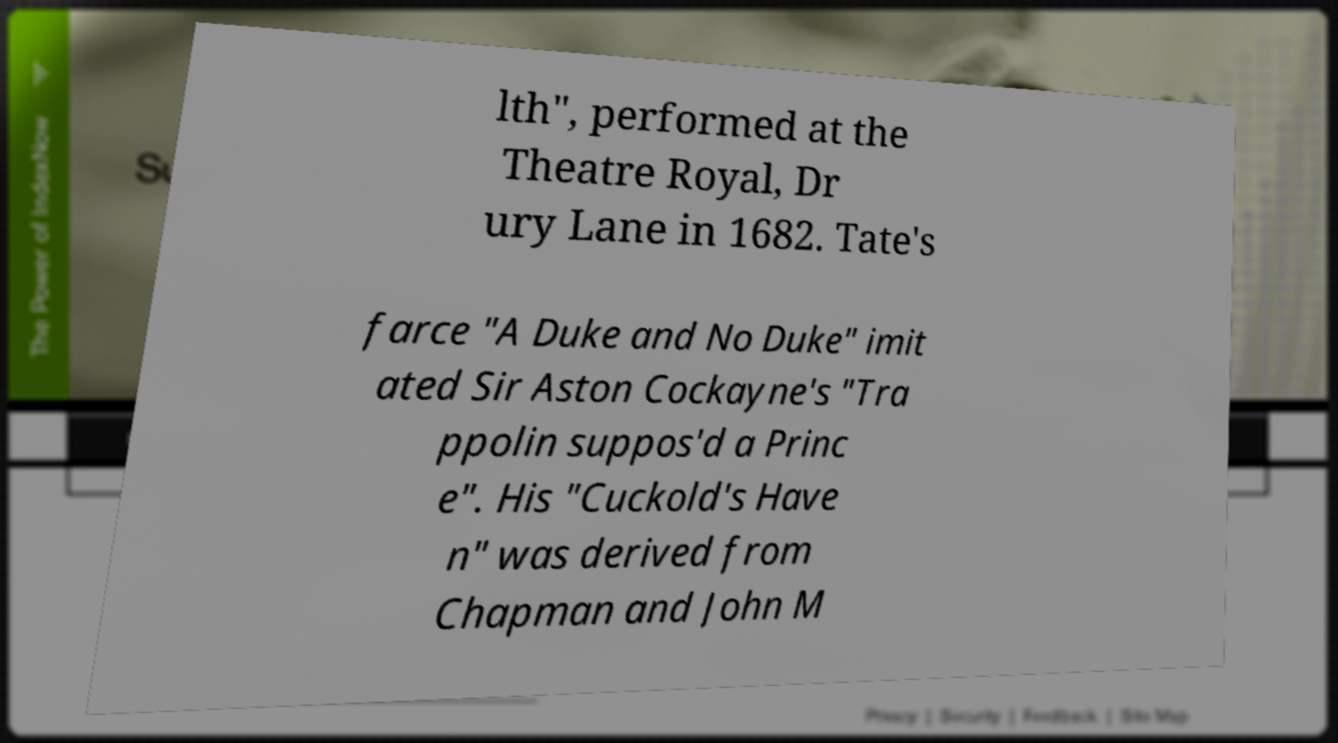Please read and relay the text visible in this image. What does it say? lth", performed at the Theatre Royal, Dr ury Lane in 1682. Tate's farce "A Duke and No Duke" imit ated Sir Aston Cockayne's "Tra ppolin suppos'd a Princ e". His "Cuckold's Have n" was derived from Chapman and John M 